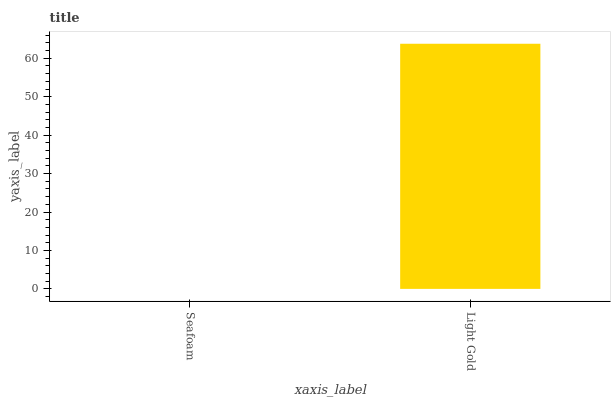Is Seafoam the minimum?
Answer yes or no. Yes. Is Light Gold the maximum?
Answer yes or no. Yes. Is Light Gold the minimum?
Answer yes or no. No. Is Light Gold greater than Seafoam?
Answer yes or no. Yes. Is Seafoam less than Light Gold?
Answer yes or no. Yes. Is Seafoam greater than Light Gold?
Answer yes or no. No. Is Light Gold less than Seafoam?
Answer yes or no. No. Is Light Gold the high median?
Answer yes or no. Yes. Is Seafoam the low median?
Answer yes or no. Yes. Is Seafoam the high median?
Answer yes or no. No. Is Light Gold the low median?
Answer yes or no. No. 